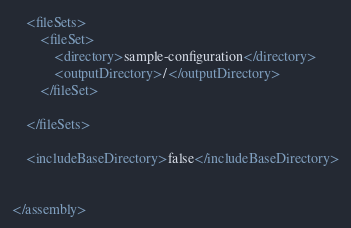<code> <loc_0><loc_0><loc_500><loc_500><_XML_>    <fileSets>
        <fileSet>
            <directory>sample-configuration</directory>
            <outputDirectory>/</outputDirectory>
        </fileSet>

    </fileSets>

    <includeBaseDirectory>false</includeBaseDirectory>


</assembly></code> 